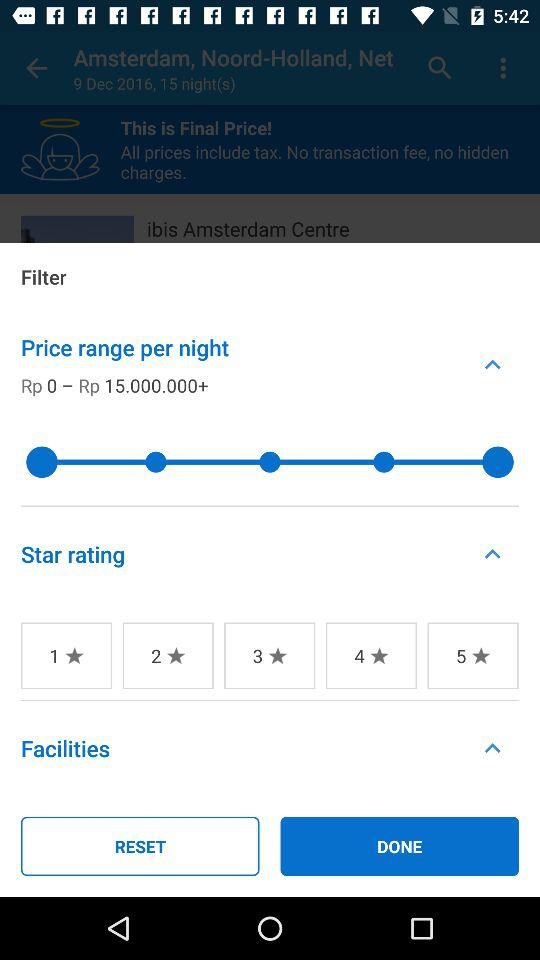How many star ratings can I choose from?
Answer the question using a single word or phrase. 5 